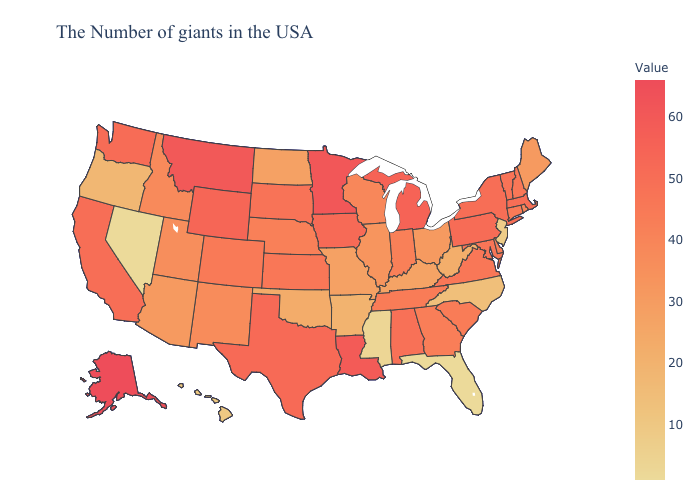Which states have the lowest value in the USA?
Concise answer only. Florida, Nevada. Does Texas have the highest value in the USA?
Short answer required. No. Does Alaska have the highest value in the West?
Quick response, please. Yes. Which states have the highest value in the USA?
Concise answer only. Alaska. Which states hav the highest value in the South?
Write a very short answer. Louisiana. Among the states that border North Dakota , does Minnesota have the highest value?
Answer briefly. Yes. 